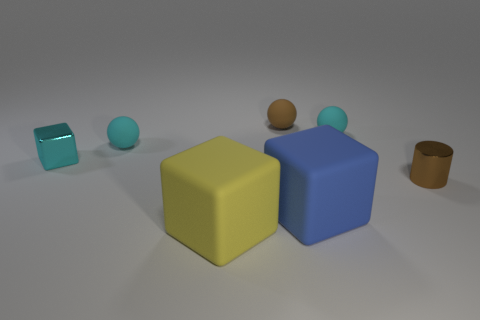What number of small matte things are the same color as the small shiny block?
Your response must be concise. 2. What size is the rubber thing that is the same color as the cylinder?
Keep it short and to the point. Small. What shape is the tiny object that is the same color as the small metallic cylinder?
Your answer should be compact. Sphere. There is a cyan object to the right of the big yellow matte cube; how big is it?
Your response must be concise. Small. What number of shiny objects are in front of the tiny cyan ball to the right of the brown object behind the cyan metallic cube?
Provide a short and direct response. 2. The large object on the left side of the brown thing behind the small cyan metallic object is what color?
Offer a terse response. Yellow. Is there a blue metal sphere of the same size as the metallic cube?
Offer a very short reply. No. There is a sphere that is right of the brown thing behind the brown shiny object to the right of the brown ball; what is it made of?
Keep it short and to the point. Rubber. What number of cubes are right of the metallic thing on the right side of the tiny cyan shiny cube?
Your answer should be very brief. 0. There is a brown sphere that is behind the yellow object; does it have the same size as the yellow matte cube?
Offer a very short reply. No. 